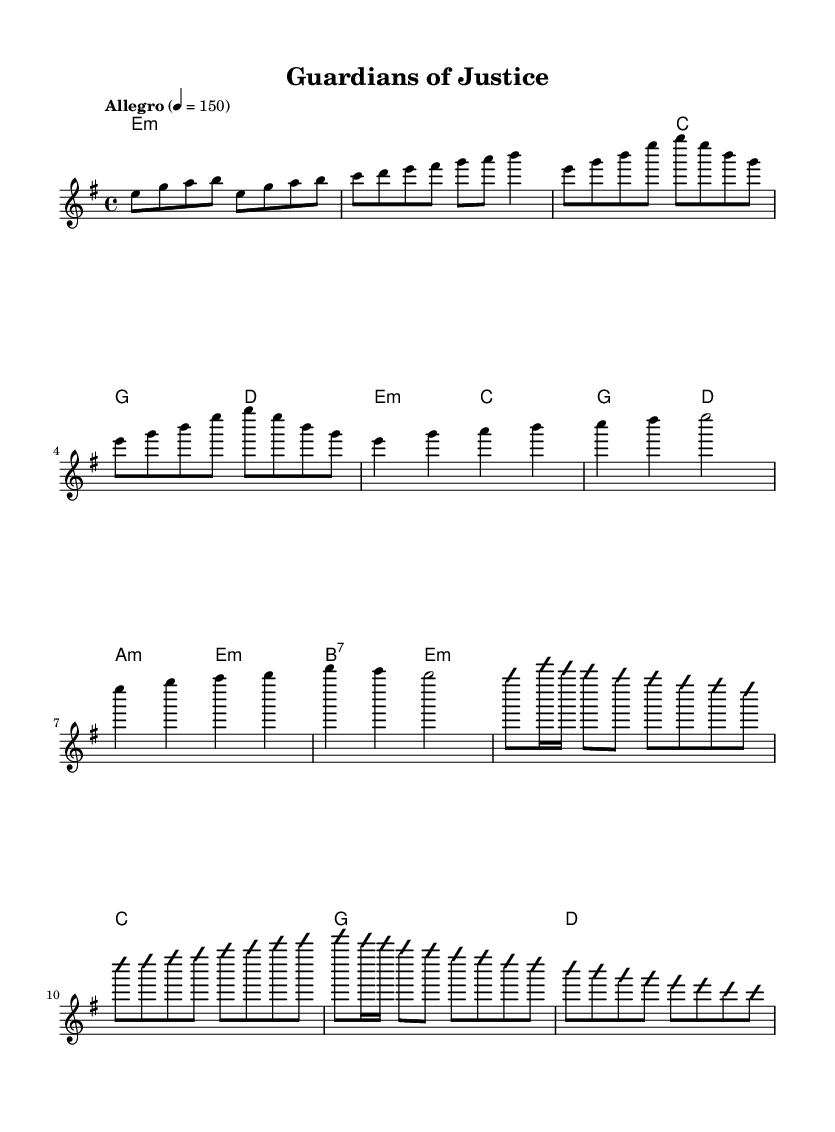What is the key signature of this music? The key signature is indicated by the key at the beginning of the staff. It shows there are no sharps or flats, indicating a minor scale. Specifically, it is E minor.
Answer: E minor What is the time signature of this music? The time signature is displayed at the start of the sheet music. It indicates that there are four beats per measure and that the quarter note gets a beat. It is represented as 4/4.
Answer: 4/4 What is the tempo marking for this piece? The tempo marking is provided in the header section of the sheet music. It states "Allegro", which is a term indicating a fast tempo, with a specified speed of 150 beats per minute.
Answer: 150 How many measures are in the chorus section? The chorus is indicated in the sheet music. By counting the number of distinct measures that make up the chorus section, we can determine there are four measures in total.
Answer: 4 What type of scale is primarily used in the melody? By analyzing the melody notes in the provided relative pitch, the notes are largely based on the E minor scale, which includes E, G, and B. Thus, the scale is a minor scale.
Answer: Minor scale How is the solo section distinguished from the other parts? The solo section is marked by the text "improvisationOn" and "improvisationOff." These markings indicate that the solo section is separate from the predetermined melody and gives space for improvisation.
Answer: Improvisation What chord is used in the introduction? The introduction is marked by the chords listed at the beginning of the music. The first chord is noted as E minor, which sets the foundation for the introductory section.
Answer: E minor 